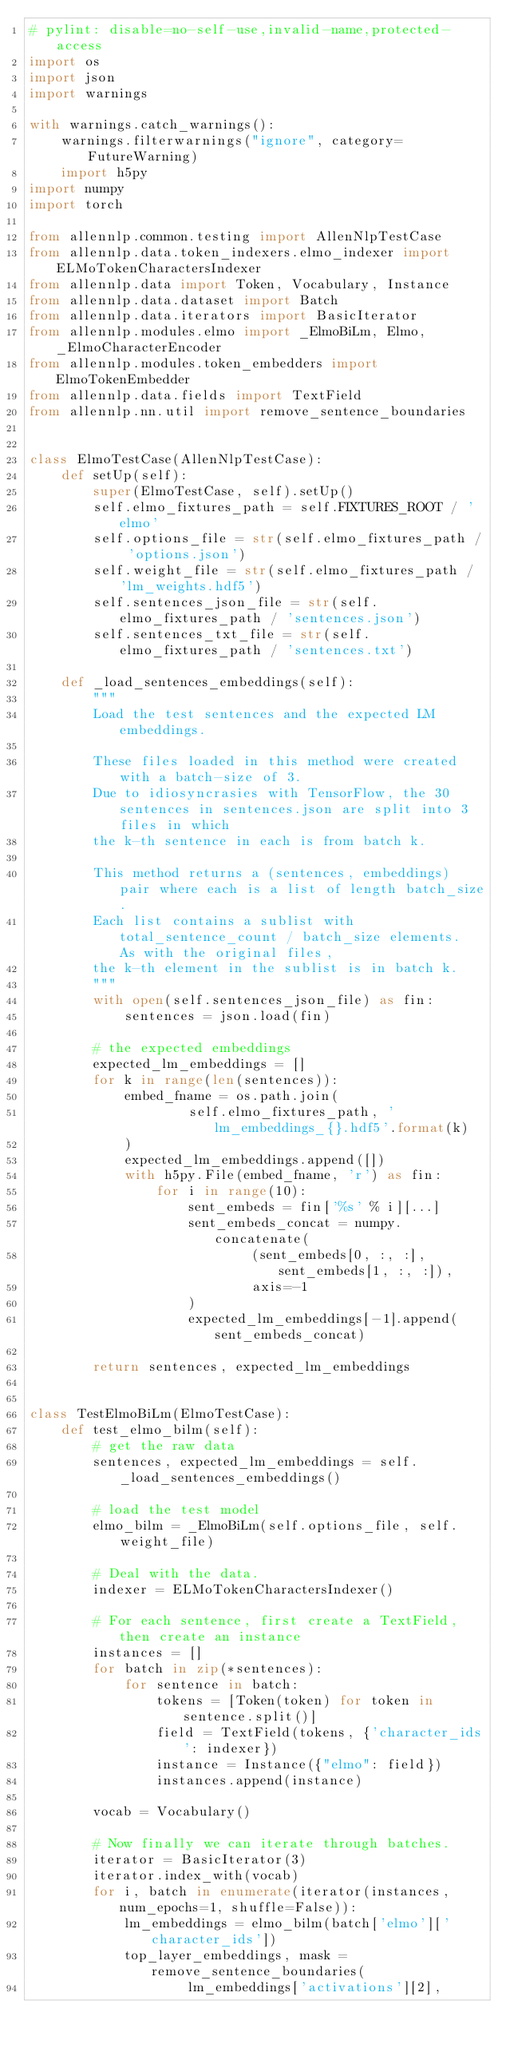<code> <loc_0><loc_0><loc_500><loc_500><_Python_># pylint: disable=no-self-use,invalid-name,protected-access
import os
import json
import warnings

with warnings.catch_warnings():
    warnings.filterwarnings("ignore", category=FutureWarning)
    import h5py
import numpy
import torch

from allennlp.common.testing import AllenNlpTestCase
from allennlp.data.token_indexers.elmo_indexer import ELMoTokenCharactersIndexer
from allennlp.data import Token, Vocabulary, Instance
from allennlp.data.dataset import Batch
from allennlp.data.iterators import BasicIterator
from allennlp.modules.elmo import _ElmoBiLm, Elmo, _ElmoCharacterEncoder
from allennlp.modules.token_embedders import ElmoTokenEmbedder
from allennlp.data.fields import TextField
from allennlp.nn.util import remove_sentence_boundaries


class ElmoTestCase(AllenNlpTestCase):
    def setUp(self):
        super(ElmoTestCase, self).setUp()
        self.elmo_fixtures_path = self.FIXTURES_ROOT / 'elmo'
        self.options_file = str(self.elmo_fixtures_path / 'options.json')
        self.weight_file = str(self.elmo_fixtures_path / 'lm_weights.hdf5')
        self.sentences_json_file = str(self.elmo_fixtures_path / 'sentences.json')
        self.sentences_txt_file = str(self.elmo_fixtures_path / 'sentences.txt')

    def _load_sentences_embeddings(self):
        """
        Load the test sentences and the expected LM embeddings.

        These files loaded in this method were created with a batch-size of 3.
        Due to idiosyncrasies with TensorFlow, the 30 sentences in sentences.json are split into 3 files in which
        the k-th sentence in each is from batch k.

        This method returns a (sentences, embeddings) pair where each is a list of length batch_size.
        Each list contains a sublist with total_sentence_count / batch_size elements.  As with the original files,
        the k-th element in the sublist is in batch k.
        """
        with open(self.sentences_json_file) as fin:
            sentences = json.load(fin)

        # the expected embeddings
        expected_lm_embeddings = []
        for k in range(len(sentences)):
            embed_fname = os.path.join(
                    self.elmo_fixtures_path, 'lm_embeddings_{}.hdf5'.format(k)
            )
            expected_lm_embeddings.append([])
            with h5py.File(embed_fname, 'r') as fin:
                for i in range(10):
                    sent_embeds = fin['%s' % i][...]
                    sent_embeds_concat = numpy.concatenate(
                            (sent_embeds[0, :, :], sent_embeds[1, :, :]),
                            axis=-1
                    )
                    expected_lm_embeddings[-1].append(sent_embeds_concat)

        return sentences, expected_lm_embeddings


class TestElmoBiLm(ElmoTestCase):
    def test_elmo_bilm(self):
        # get the raw data
        sentences, expected_lm_embeddings = self._load_sentences_embeddings()

        # load the test model
        elmo_bilm = _ElmoBiLm(self.options_file, self.weight_file)

        # Deal with the data.
        indexer = ELMoTokenCharactersIndexer()

        # For each sentence, first create a TextField, then create an instance
        instances = []
        for batch in zip(*sentences):
            for sentence in batch:
                tokens = [Token(token) for token in sentence.split()]
                field = TextField(tokens, {'character_ids': indexer})
                instance = Instance({"elmo": field})
                instances.append(instance)

        vocab = Vocabulary()

        # Now finally we can iterate through batches.
        iterator = BasicIterator(3)
        iterator.index_with(vocab)
        for i, batch in enumerate(iterator(instances, num_epochs=1, shuffle=False)):
            lm_embeddings = elmo_bilm(batch['elmo']['character_ids'])
            top_layer_embeddings, mask = remove_sentence_boundaries(
                    lm_embeddings['activations'][2],</code> 